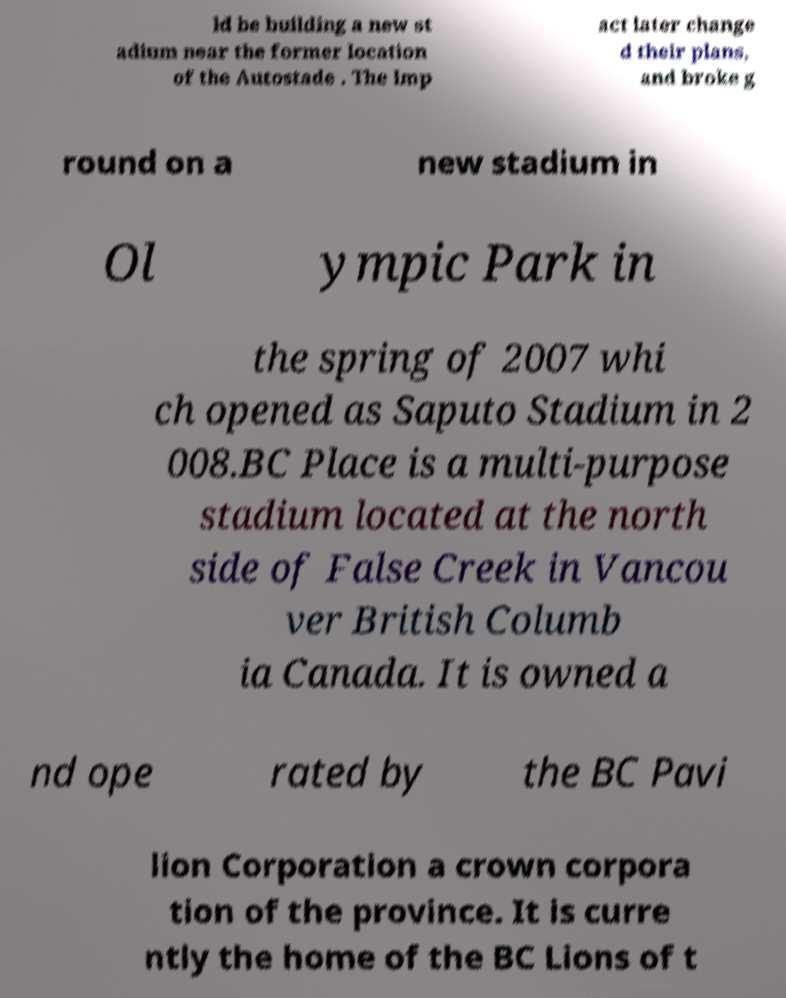There's text embedded in this image that I need extracted. Can you transcribe it verbatim? ld be building a new st adium near the former location of the Autostade . The Imp act later change d their plans, and broke g round on a new stadium in Ol ympic Park in the spring of 2007 whi ch opened as Saputo Stadium in 2 008.BC Place is a multi-purpose stadium located at the north side of False Creek in Vancou ver British Columb ia Canada. It is owned a nd ope rated by the BC Pavi lion Corporation a crown corpora tion of the province. It is curre ntly the home of the BC Lions of t 